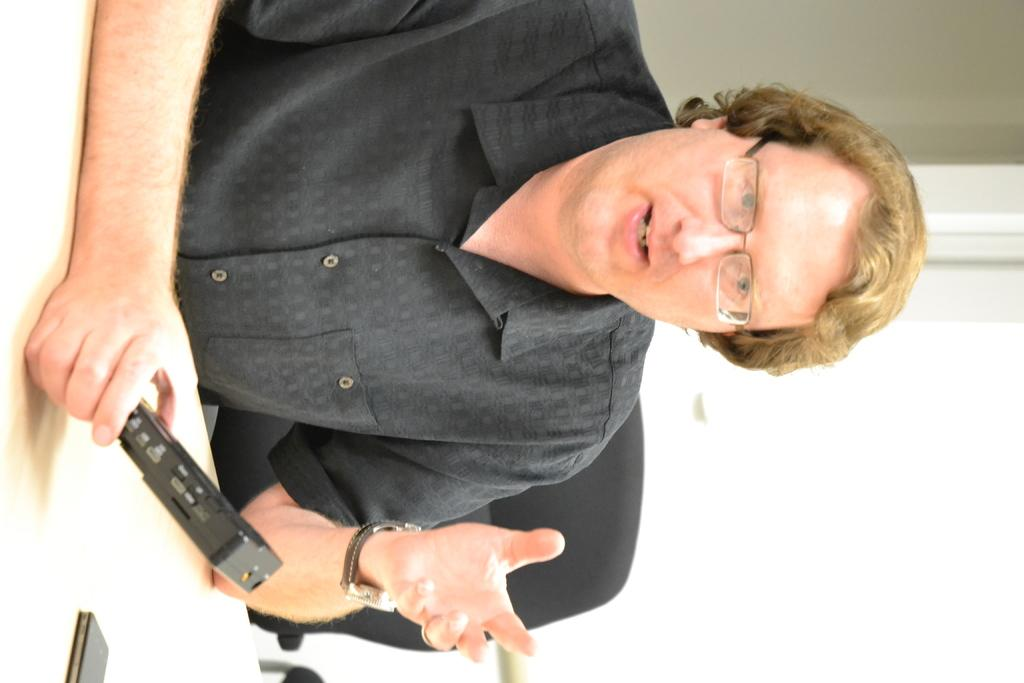Who is present in the image? There is a man in the image. What is the man doing in the image? The man is sitting on a chair. What is the man holding in the image? The man is holding an object. What is in front of the man in the image? There is a table in front of the man. What is behind the man in the image? There is a wall behind the man. What type of steel is the man gripping in the image? There is no steel present in the image, and the man is not gripping anything. 